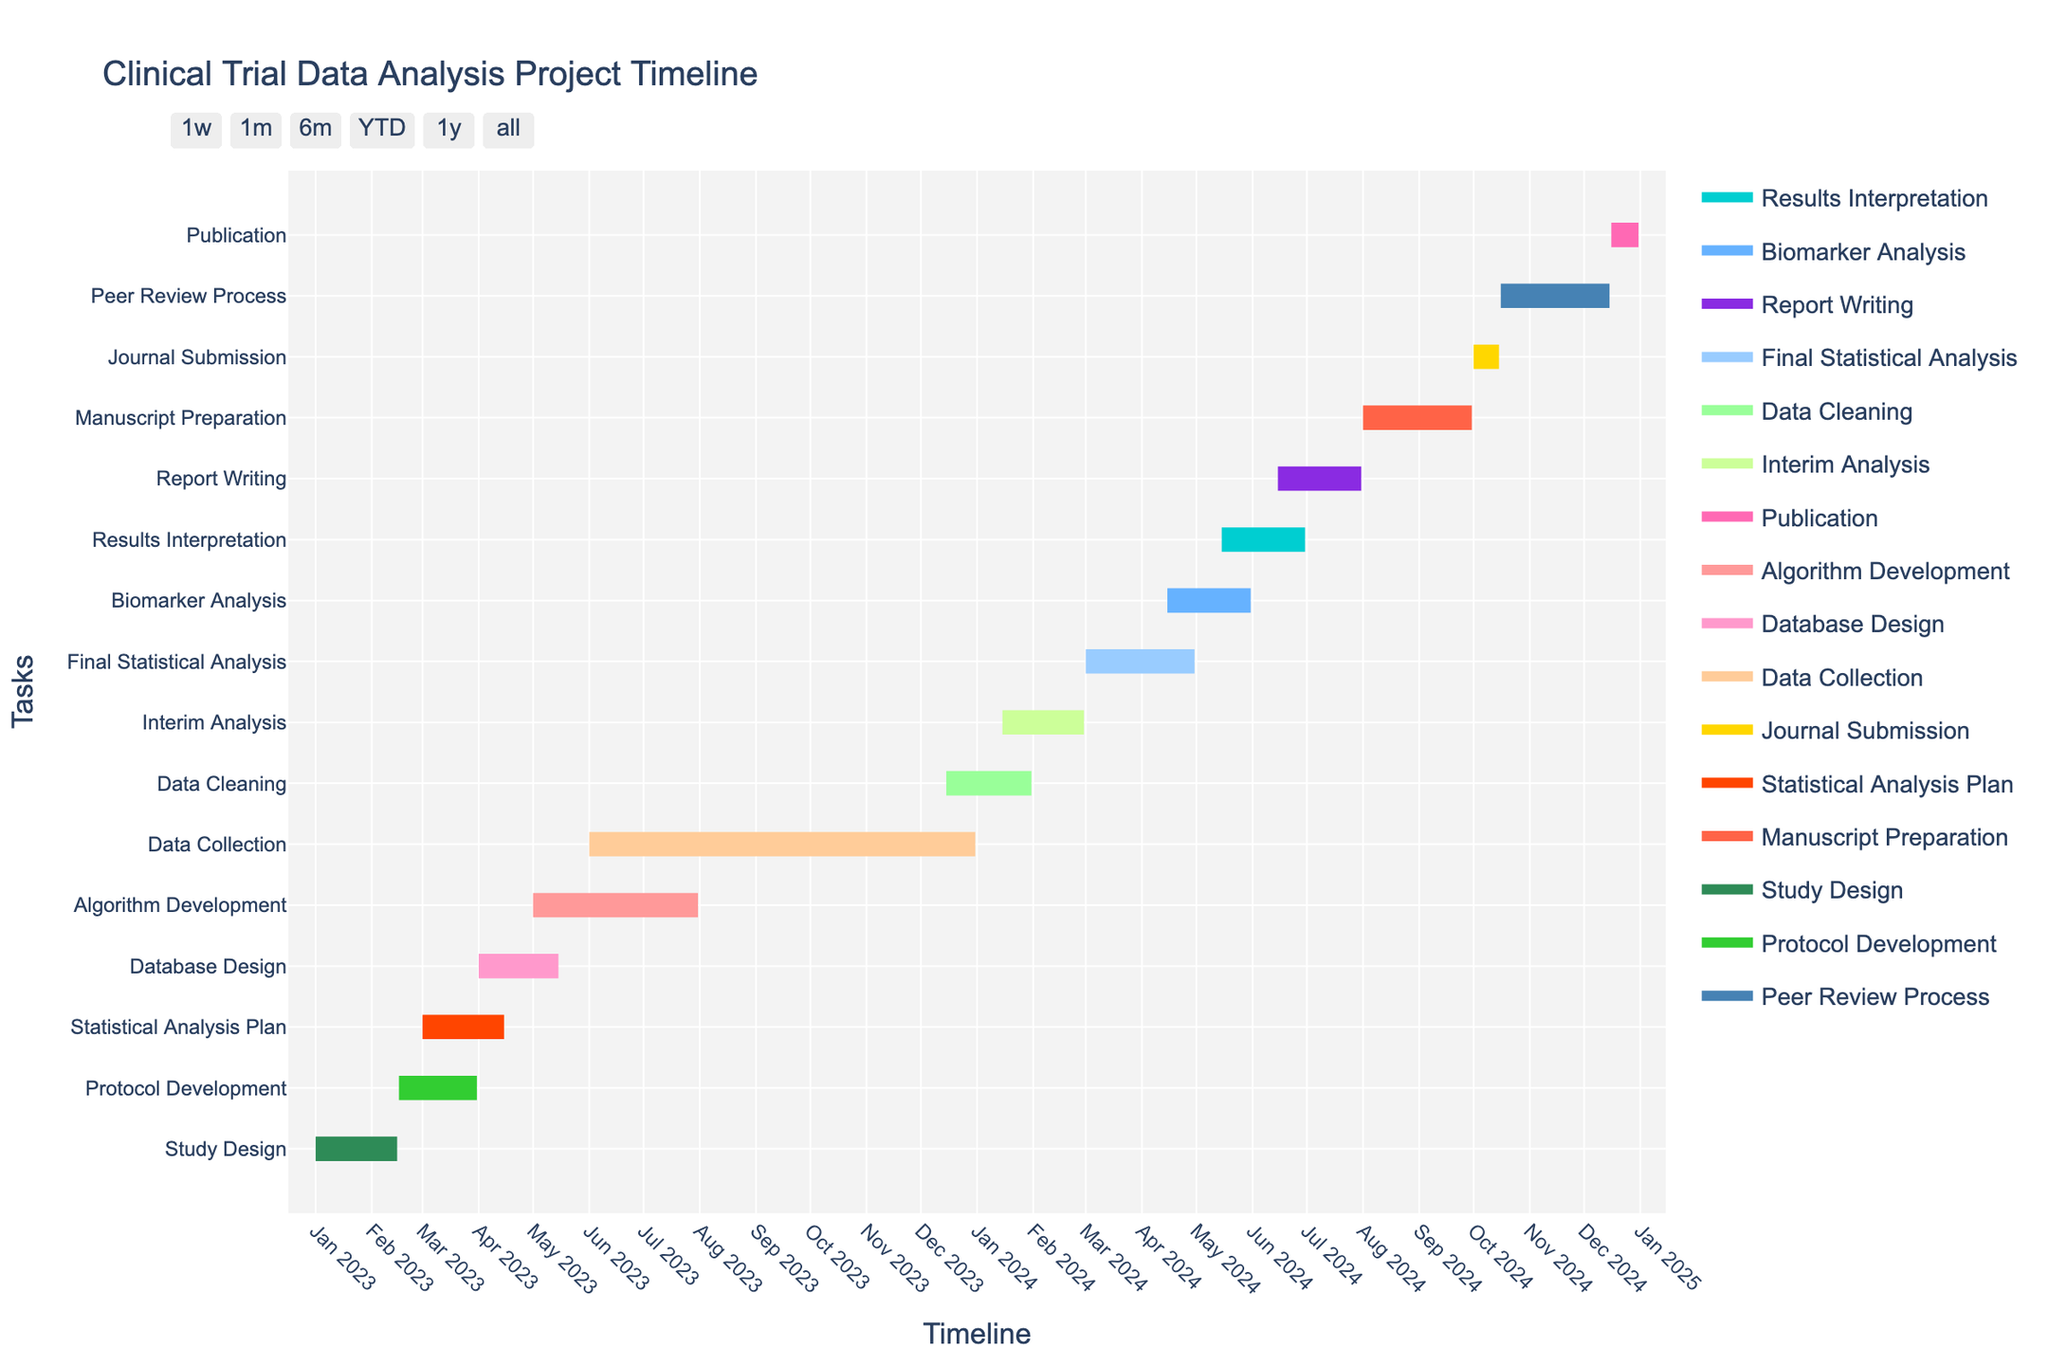What's the title of the Gantt Chart? The title of the Gantt Chart is typically displayed prominently at the top of the chart.
Answer: Clinical Trial Data Analysis Project Timeline When does Database Design start and end? To find the start and end dates of Database Design, look for the task label "Database Design" on the y-axis and then trace horizontally to the start and end points on the timeline.
Answer: 2023-04-01 to 2023-05-15 Which tasks overlap with the Algorithm Development phase? To identify overlapping tasks, locate the "Algorithm Development" bar and check for other task bars that intersect with it horizontally.
Answer: Data Collection How long is the Data Cleaning phase? Calculate the duration by subtracting the start date of Data Cleaning from its end date.
Answer: 46 days Which task has the longest duration? Find the task whose duration bar spans the longest distance on the x-axis.
Answer: Data Collection What is the gap between the end of the Protocol Development phase and the start of Statistical Analysis Plan? Subtract the end date of Protocol Development from the start date of Statistical Analysis Plan to find the gap.
Answer: -30 days (overlap) Which phases are undertaken simultaneously during the month of April 2024? Identify the tasks that have dates falling within April 2024 by checking the x-axis timeline and the respective task bars.
Answer: Final Statistical Analysis, Biomarker Analysis What is the sequence of tasks in the second quarter of 2024? Look at the tasks that occur in April, May, and June 2024 and order them based on their start dates.
Answer: Final Statistical Analysis, Biomarker Analysis, Results Interpretation Compare the durations of Database Design and Protocol Development. Which one is longer? Calculate the duration of each by subtracting their start dates from their end dates and compare.
Answer: Protocol Development is longer What tasks happen after Report Writing? Look at tasks whose start dates are after the end date of Report Writing by following the sequence of events on the timeline.
Answer: Manuscript Preparation, Journal Submission, Peer Review Process, Publication 